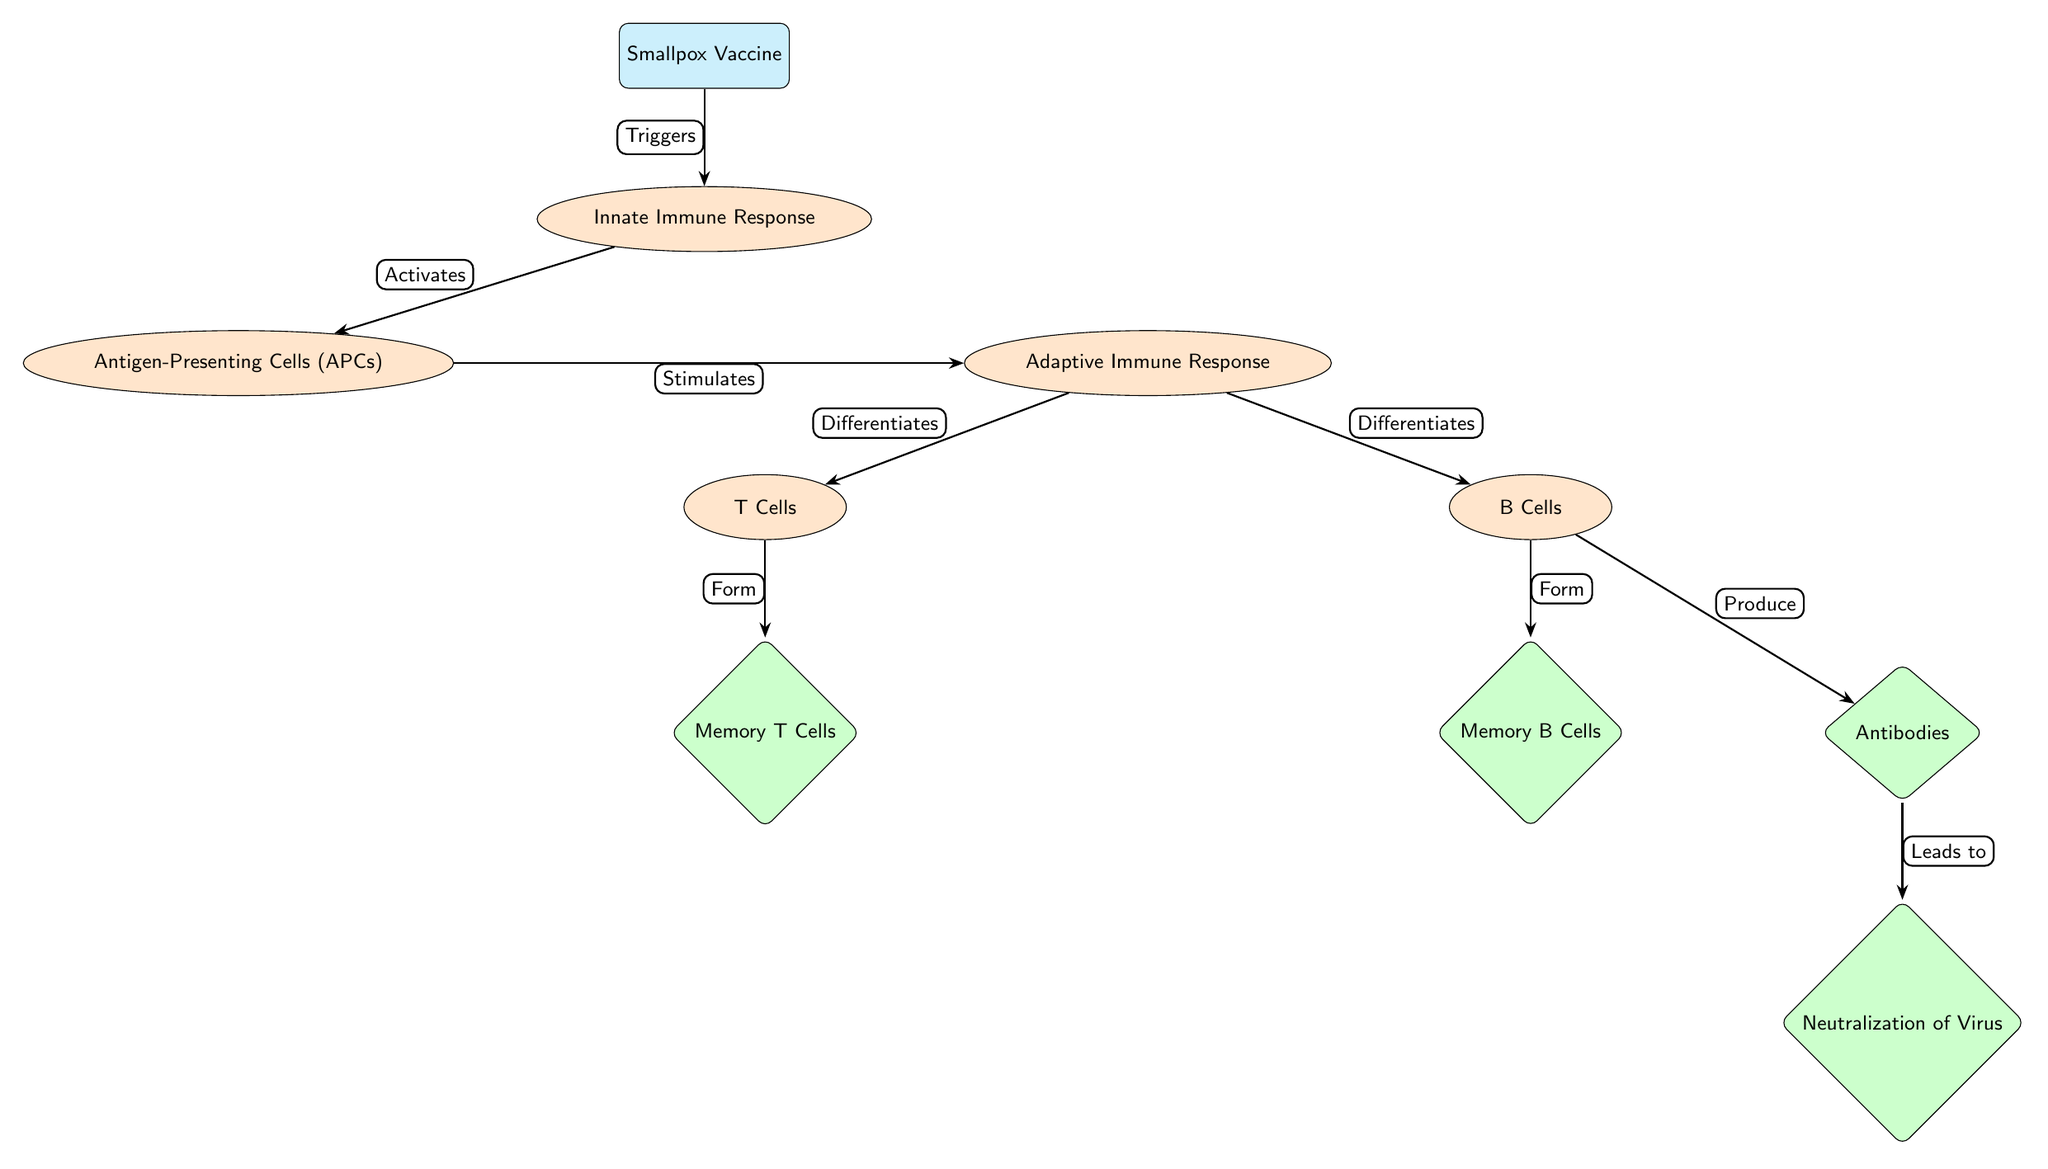What is the first node in the diagram? The first node represents the initiation of the process, and it is labeled "Smallpox Vaccine."
Answer: Smallpox Vaccine How many result nodes are present in the diagram? The result nodes are indicated by diamonds, and there are three result nodes: "Memory T Cells," "Memory B Cells," and "Antibodies."
Answer: 3 What does the Innate Immune Response activate? The Innate Immune Response activates a specific type of cell, which is called "Antigen-Presenting Cells (APCs)."
Answer: Antigen-Presenting Cells (APCs) Which process differentiates into T Cells and B Cells? The Adaptive Immune Response is the process that differentiates into both T Cells and B Cells, as indicated by the arrows leading from it.
Answer: Adaptive Immune Response What results from the production of B Cells? B Cells produce "Antibodies," which are crucial for the immune response. This relationship is shown by the directed edge from B Cells to Antibodies.
Answer: Antibodies Explain the final outcome of the immune response process after the Smallpox Vaccine. The diagram details a flow starting from the vaccine, triggering various immune responses, ultimately leading to the creation of antibodies that neutralize the virus. The sequence shows that B Cells produce antibodies, leading to the final outcome of neutralization of the virus.
Answer: Neutralization of Virus What triggers the Innate Immune Response? The triggering factor for the Innate Immune Response, as shown in the diagram, is the "Smallpox Vaccine."
Answer: Smallpox Vaccine What type of cells are formed from T Cells? The process indicated in the diagram shows that T Cells lead to the formation of "Memory T Cells."
Answer: Memory T Cells What is the relationship between B Cells and Antibodies? According to the diagram, B Cells produce Antibodies, which indicates a direct connection between these two nodes.
Answer: Produce 